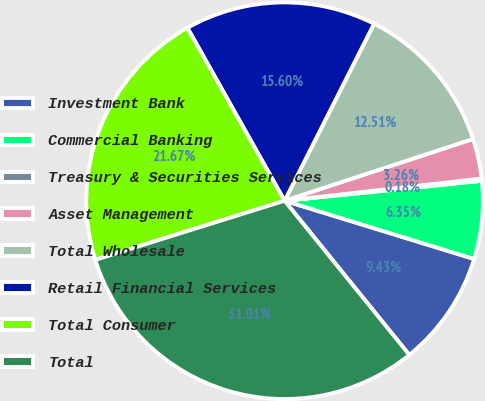Convert chart. <chart><loc_0><loc_0><loc_500><loc_500><pie_chart><fcel>Investment Bank<fcel>Commercial Banking<fcel>Treasury & Securities Services<fcel>Asset Management<fcel>Total Wholesale<fcel>Retail Financial Services<fcel>Total Consumer<fcel>Total<nl><fcel>9.43%<fcel>6.35%<fcel>0.18%<fcel>3.26%<fcel>12.51%<fcel>15.6%<fcel>21.67%<fcel>31.01%<nl></chart> 